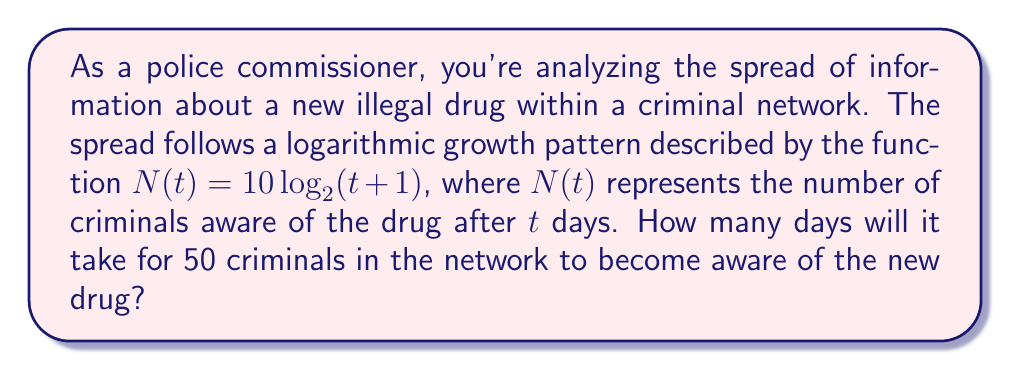Can you answer this question? To solve this problem, we need to use the given logarithmic function and solve for $t$ when $N(t) = 50$. Let's approach this step-by-step:

1) We start with the equation:
   $N(t) = 10 \log_2(t+1)$

2) We want to find $t$ when $N(t) = 50$, so we substitute:
   $50 = 10 \log_2(t+1)$

3) Divide both sides by 10:
   $5 = \log_2(t+1)$

4) To solve for $t$, we need to apply the inverse function (exponential) to both sides:
   $2^5 = t+1$

5) Calculate $2^5$:
   $32 = t+1$

6) Subtract 1 from both sides:
   $31 = t$

Therefore, it will take 31 days for 50 criminals in the network to become aware of the new drug.
Answer: 31 days 